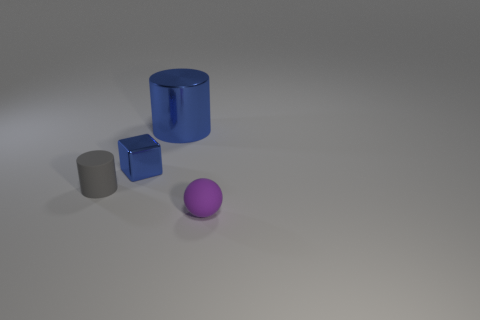Add 2 blocks. How many objects exist? 6 Subtract 2 cylinders. How many cylinders are left? 0 Subtract all red cubes. How many gray cylinders are left? 1 Add 2 small metal cubes. How many small metal cubes are left? 3 Add 4 brown balls. How many brown balls exist? 4 Subtract 0 cyan blocks. How many objects are left? 4 Subtract all cubes. How many objects are left? 3 Subtract all gray cubes. Subtract all brown cylinders. How many cubes are left? 1 Subtract all gray rubber objects. Subtract all balls. How many objects are left? 2 